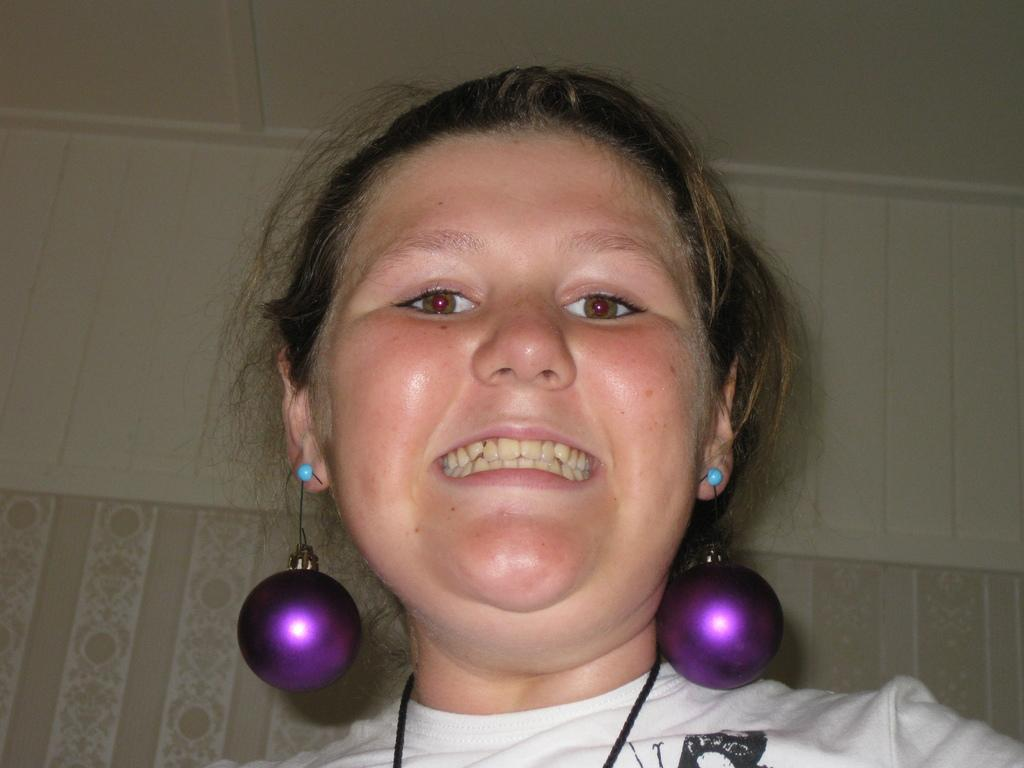Who is the main subject in the image? There is a woman in the image. What is the woman wearing in the image? The woman is wearing big round purple earrings. What is the woman doing in the image? The woman is looking at someone and smiling. How many kitties are sitting on the woman's lap in the image? There are no kitties present in the image. What type of bear can be seen in the background of the image? There is no bear present in the image. 